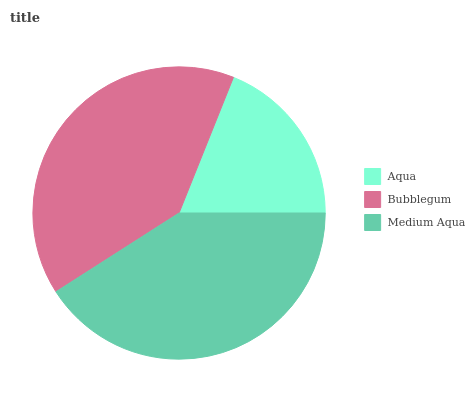Is Aqua the minimum?
Answer yes or no. Yes. Is Medium Aqua the maximum?
Answer yes or no. Yes. Is Bubblegum the minimum?
Answer yes or no. No. Is Bubblegum the maximum?
Answer yes or no. No. Is Bubblegum greater than Aqua?
Answer yes or no. Yes. Is Aqua less than Bubblegum?
Answer yes or no. Yes. Is Aqua greater than Bubblegum?
Answer yes or no. No. Is Bubblegum less than Aqua?
Answer yes or no. No. Is Bubblegum the high median?
Answer yes or no. Yes. Is Bubblegum the low median?
Answer yes or no. Yes. Is Medium Aqua the high median?
Answer yes or no. No. Is Aqua the low median?
Answer yes or no. No. 